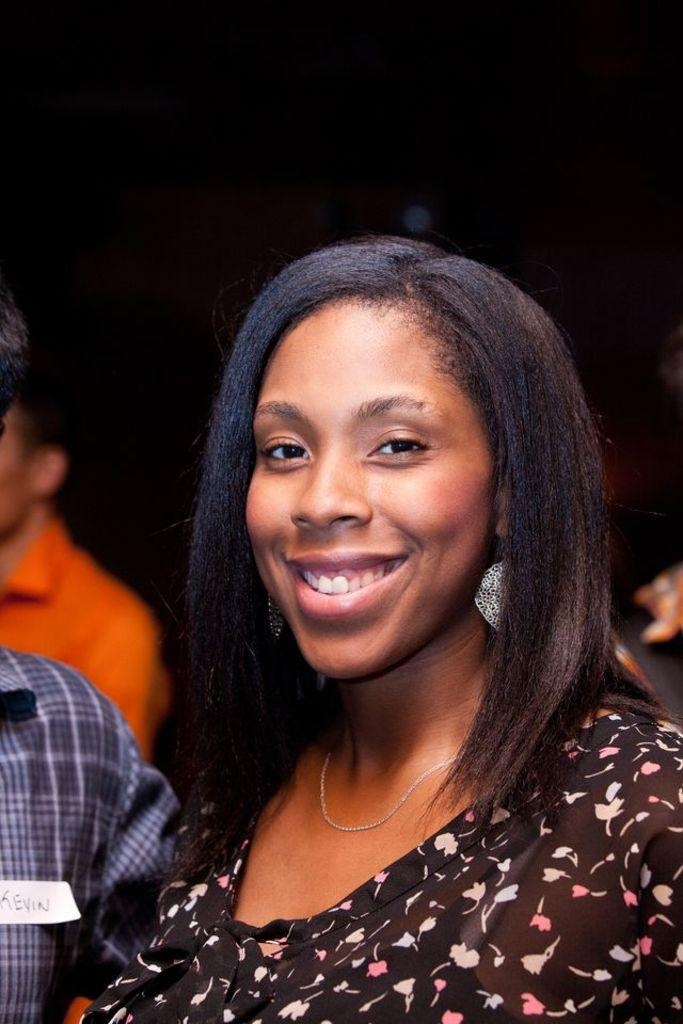Who is present in the image? There is a woman in the image. What is the woman doing in the image? The woman is smiling in the image. Can you describe the people around the woman? There is a group of people in the image. What can be seen in the background of the image? The background of the image is dark. What type of business is being conducted in the image? There is no indication of any business activity in the image. Can you see a zipper on the woman's clothing in the image? There is no information about the woman's clothing or the presence of a zipper in the image. 